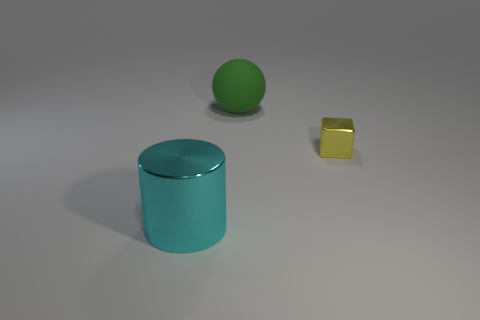What is the shape of the shiny thing that is in front of the metallic object that is on the right side of the big object that is behind the yellow object?
Your answer should be very brief. Cylinder. What is the color of the object that is in front of the large green rubber object and to the left of the tiny yellow shiny cube?
Provide a succinct answer. Cyan. What shape is the metallic thing that is left of the yellow shiny object?
Your answer should be compact. Cylinder. What is the shape of the tiny yellow thing that is the same material as the big cyan cylinder?
Ensure brevity in your answer.  Cube. How many shiny things are either large things or big cyan cylinders?
Offer a very short reply. 1. There is a large object that is to the right of the object left of the large green matte object; how many cyan metallic things are in front of it?
Offer a terse response. 1. There is a metal object that is left of the small metallic block; is it the same size as the thing behind the block?
Ensure brevity in your answer.  Yes. What number of large objects are cylinders or blue metal balls?
Give a very brief answer. 1. What is the material of the yellow cube?
Offer a terse response. Metal. What material is the object that is both in front of the big green ball and behind the big cyan metal cylinder?
Make the answer very short. Metal. 